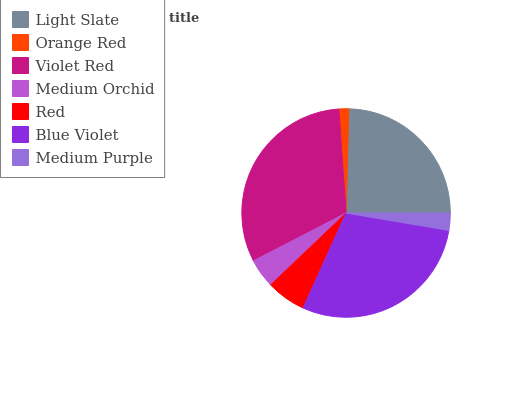Is Orange Red the minimum?
Answer yes or no. Yes. Is Violet Red the maximum?
Answer yes or no. Yes. Is Violet Red the minimum?
Answer yes or no. No. Is Orange Red the maximum?
Answer yes or no. No. Is Violet Red greater than Orange Red?
Answer yes or no. Yes. Is Orange Red less than Violet Red?
Answer yes or no. Yes. Is Orange Red greater than Violet Red?
Answer yes or no. No. Is Violet Red less than Orange Red?
Answer yes or no. No. Is Red the high median?
Answer yes or no. Yes. Is Red the low median?
Answer yes or no. Yes. Is Blue Violet the high median?
Answer yes or no. No. Is Medium Purple the low median?
Answer yes or no. No. 